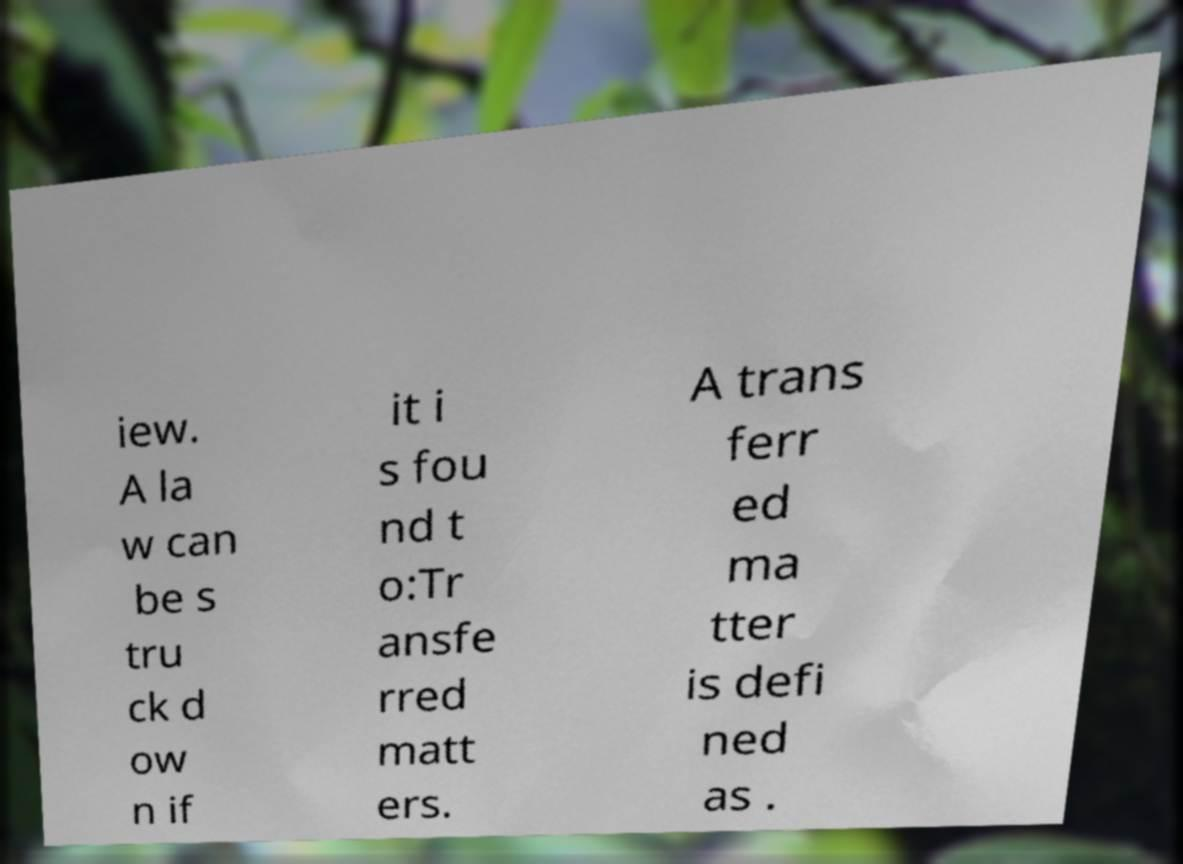Can you read and provide the text displayed in the image?This photo seems to have some interesting text. Can you extract and type it out for me? iew. A la w can be s tru ck d ow n if it i s fou nd t o:Tr ansfe rred matt ers. A trans ferr ed ma tter is defi ned as . 